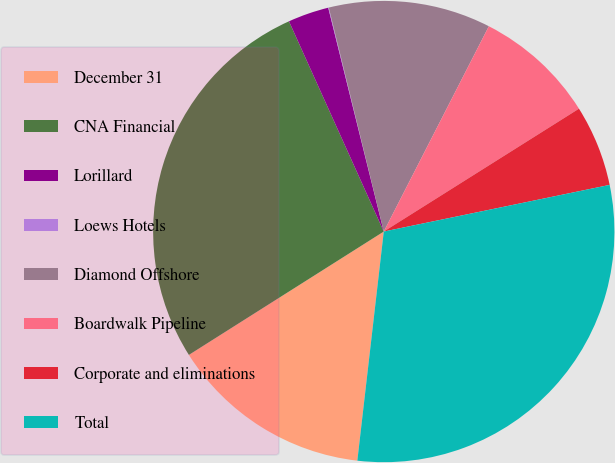Convert chart. <chart><loc_0><loc_0><loc_500><loc_500><pie_chart><fcel>December 31<fcel>CNA Financial<fcel>Lorillard<fcel>Loews Hotels<fcel>Diamond Offshore<fcel>Boardwalk Pipeline<fcel>Corporate and eliminations<fcel>Total<nl><fcel>14.19%<fcel>27.24%<fcel>2.87%<fcel>0.04%<fcel>11.36%<fcel>8.53%<fcel>5.7%<fcel>30.07%<nl></chart> 